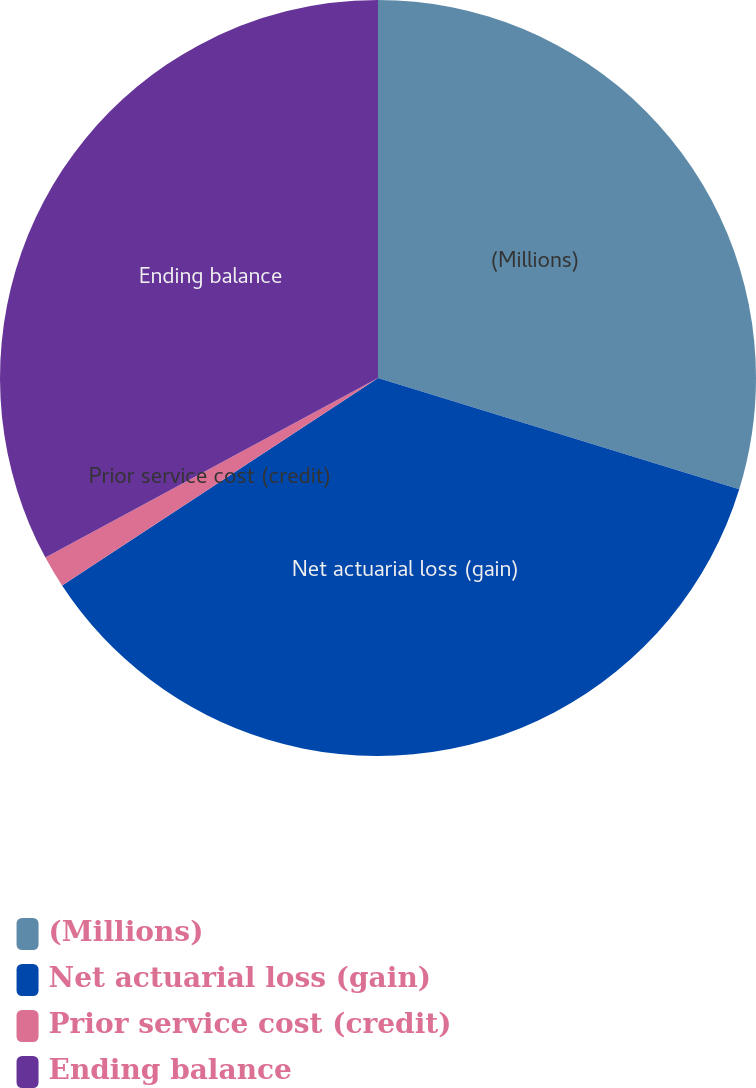Convert chart to OTSL. <chart><loc_0><loc_0><loc_500><loc_500><pie_chart><fcel>(Millions)<fcel>Net actuarial loss (gain)<fcel>Prior service cost (credit)<fcel>Ending balance<nl><fcel>29.76%<fcel>35.99%<fcel>1.37%<fcel>32.88%<nl></chart> 